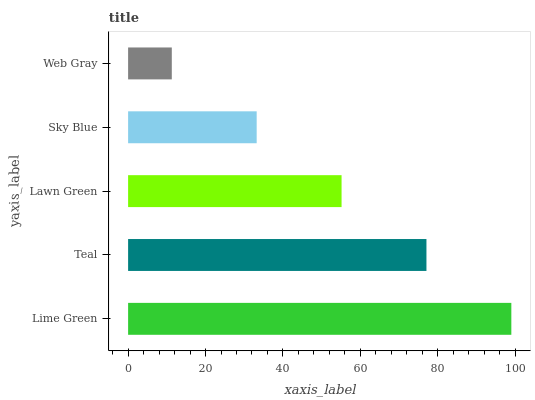Is Web Gray the minimum?
Answer yes or no. Yes. Is Lime Green the maximum?
Answer yes or no. Yes. Is Teal the minimum?
Answer yes or no. No. Is Teal the maximum?
Answer yes or no. No. Is Lime Green greater than Teal?
Answer yes or no. Yes. Is Teal less than Lime Green?
Answer yes or no. Yes. Is Teal greater than Lime Green?
Answer yes or no. No. Is Lime Green less than Teal?
Answer yes or no. No. Is Lawn Green the high median?
Answer yes or no. Yes. Is Lawn Green the low median?
Answer yes or no. Yes. Is Teal the high median?
Answer yes or no. No. Is Teal the low median?
Answer yes or no. No. 